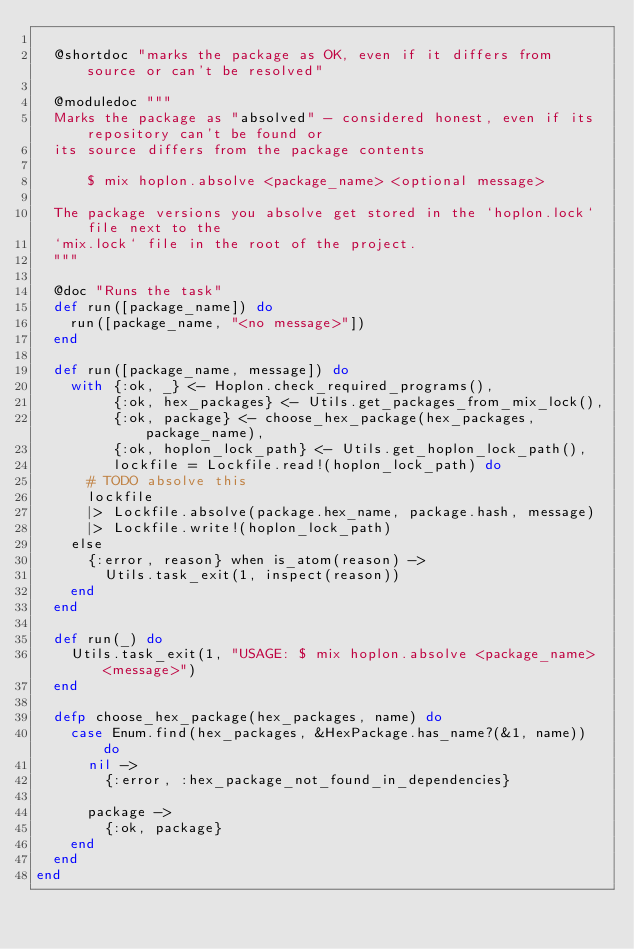<code> <loc_0><loc_0><loc_500><loc_500><_Elixir_>
  @shortdoc "marks the package as OK, even if it differs from source or can't be resolved"

  @moduledoc """
  Marks the package as "absolved" - considered honest, even if its repository can't be found or
  its source differs from the package contents

      $ mix hoplon.absolve <package_name> <optional message>

  The package versions you absolve get stored in the `hoplon.lock` file next to the
  `mix.lock` file in the root of the project.
  """

  @doc "Runs the task"
  def run([package_name]) do
    run([package_name, "<no message>"])
  end

  def run([package_name, message]) do
    with {:ok, _} <- Hoplon.check_required_programs(),
         {:ok, hex_packages} <- Utils.get_packages_from_mix_lock(),
         {:ok, package} <- choose_hex_package(hex_packages, package_name),
         {:ok, hoplon_lock_path} <- Utils.get_hoplon_lock_path(),
         lockfile = Lockfile.read!(hoplon_lock_path) do
      # TODO absolve this
      lockfile
      |> Lockfile.absolve(package.hex_name, package.hash, message)
      |> Lockfile.write!(hoplon_lock_path)
    else
      {:error, reason} when is_atom(reason) ->
        Utils.task_exit(1, inspect(reason))
    end
  end

  def run(_) do
    Utils.task_exit(1, "USAGE: $ mix hoplon.absolve <package_name> <message>")
  end

  defp choose_hex_package(hex_packages, name) do
    case Enum.find(hex_packages, &HexPackage.has_name?(&1, name)) do
      nil ->
        {:error, :hex_package_not_found_in_dependencies}

      package ->
        {:ok, package}
    end
  end
end
</code> 